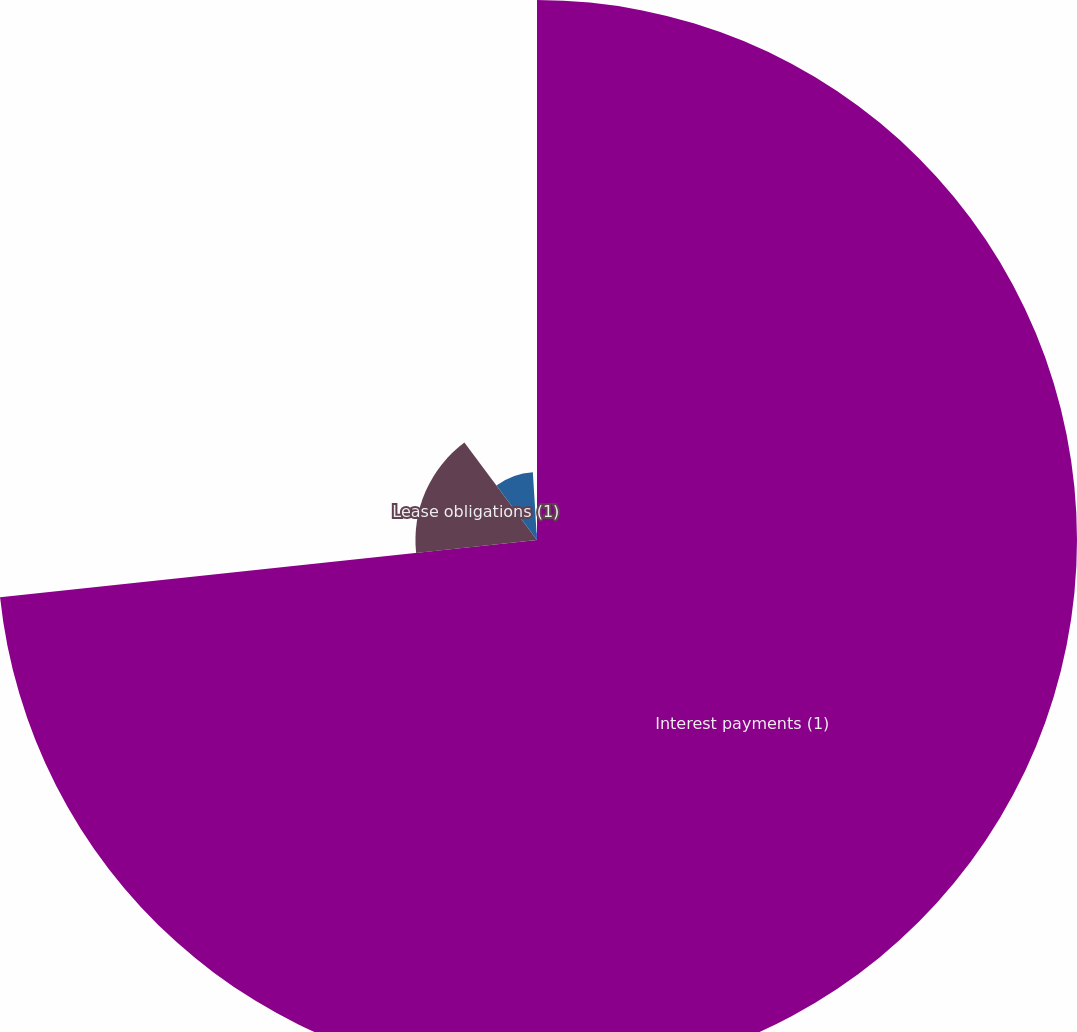<chart> <loc_0><loc_0><loc_500><loc_500><pie_chart><fcel>Interest payments (1)<fcel>Lease obligations (1)<fcel>Purchase obligations (1)<fcel>Minimum royalty obligations<nl><fcel>73.3%<fcel>16.5%<fcel>9.22%<fcel>0.97%<nl></chart> 